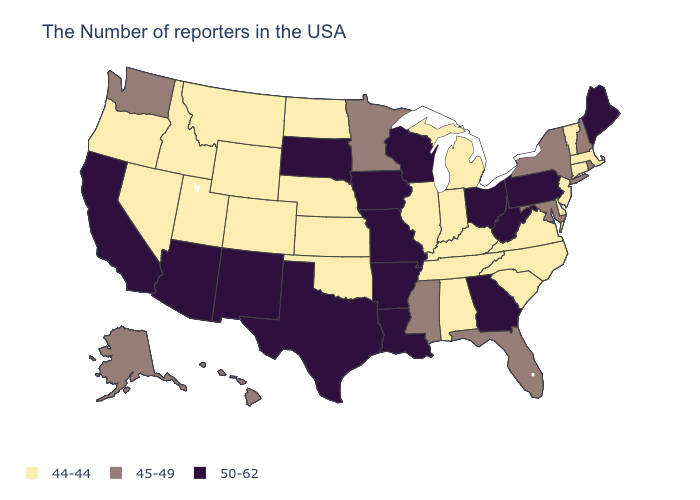What is the highest value in states that border Arkansas?
Write a very short answer. 50-62. Among the states that border Massachusetts , which have the highest value?
Give a very brief answer. Rhode Island, New Hampshire, New York. What is the highest value in states that border Illinois?
Keep it brief. 50-62. What is the value of Pennsylvania?
Write a very short answer. 50-62. Among the states that border Washington , which have the lowest value?
Keep it brief. Idaho, Oregon. What is the highest value in the Northeast ?
Short answer required. 50-62. What is the value of Delaware?
Give a very brief answer. 44-44. Does North Dakota have the same value as Washington?
Give a very brief answer. No. What is the value of Louisiana?
Concise answer only. 50-62. How many symbols are there in the legend?
Short answer required. 3. How many symbols are there in the legend?
Quick response, please. 3. What is the value of Maine?
Write a very short answer. 50-62. Among the states that border New York , which have the lowest value?
Short answer required. Massachusetts, Vermont, Connecticut, New Jersey. Name the states that have a value in the range 50-62?
Quick response, please. Maine, Pennsylvania, West Virginia, Ohio, Georgia, Wisconsin, Louisiana, Missouri, Arkansas, Iowa, Texas, South Dakota, New Mexico, Arizona, California. What is the value of South Dakota?
Write a very short answer. 50-62. 